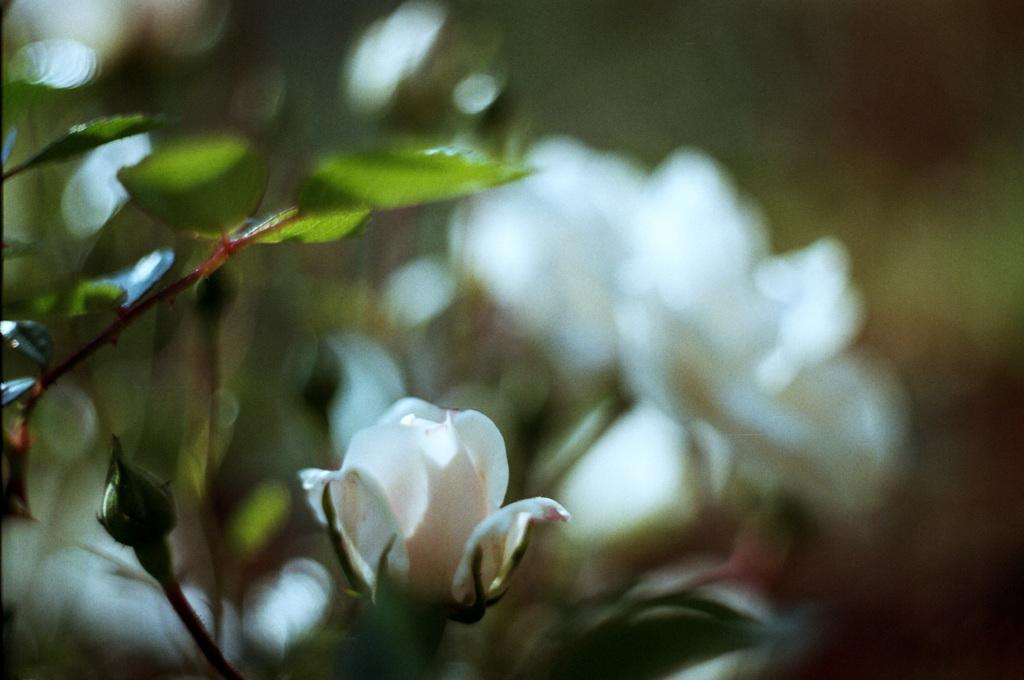What type of living organisms can be seen in the image? A: Plants can be seen in the image. What specific feature of the plants is visible in the image? The plants have flowers. What color are the flowers on the plants? The flowers are white in color. What type of lunch is being served in the image? There is no lunch present in the image; it features plants with white flowers. Are there any police officers visible in the image? There are no police officers present in the image. 